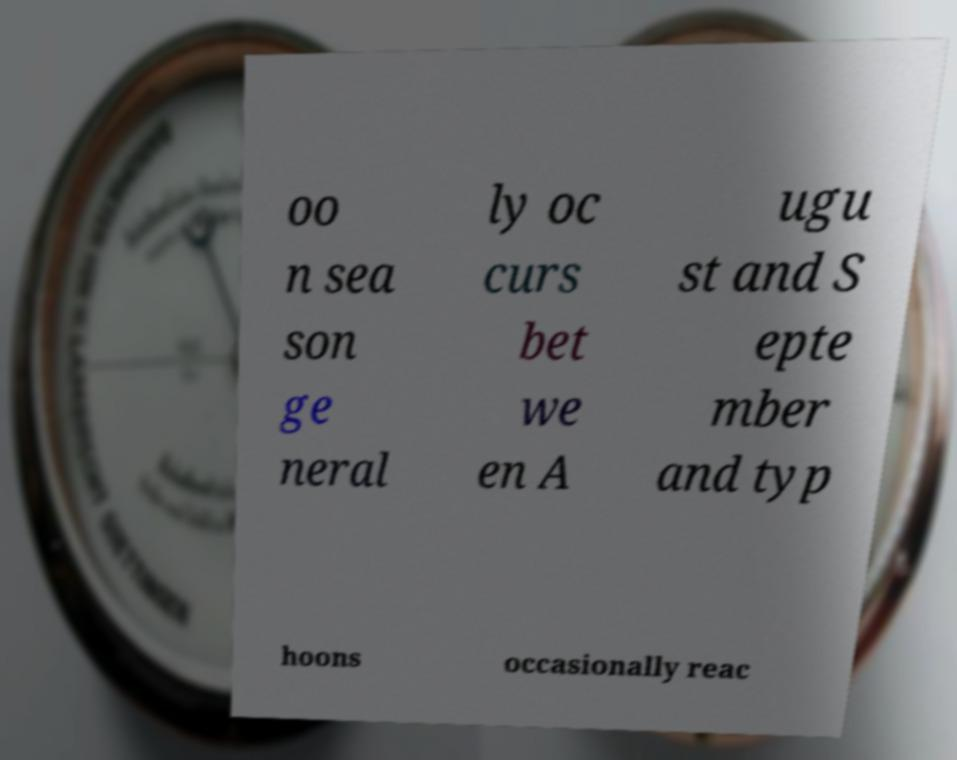Could you extract and type out the text from this image? oo n sea son ge neral ly oc curs bet we en A ugu st and S epte mber and typ hoons occasionally reac 